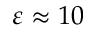Convert formula to latex. <formula><loc_0><loc_0><loc_500><loc_500>\varepsilon \approx 1 0</formula> 